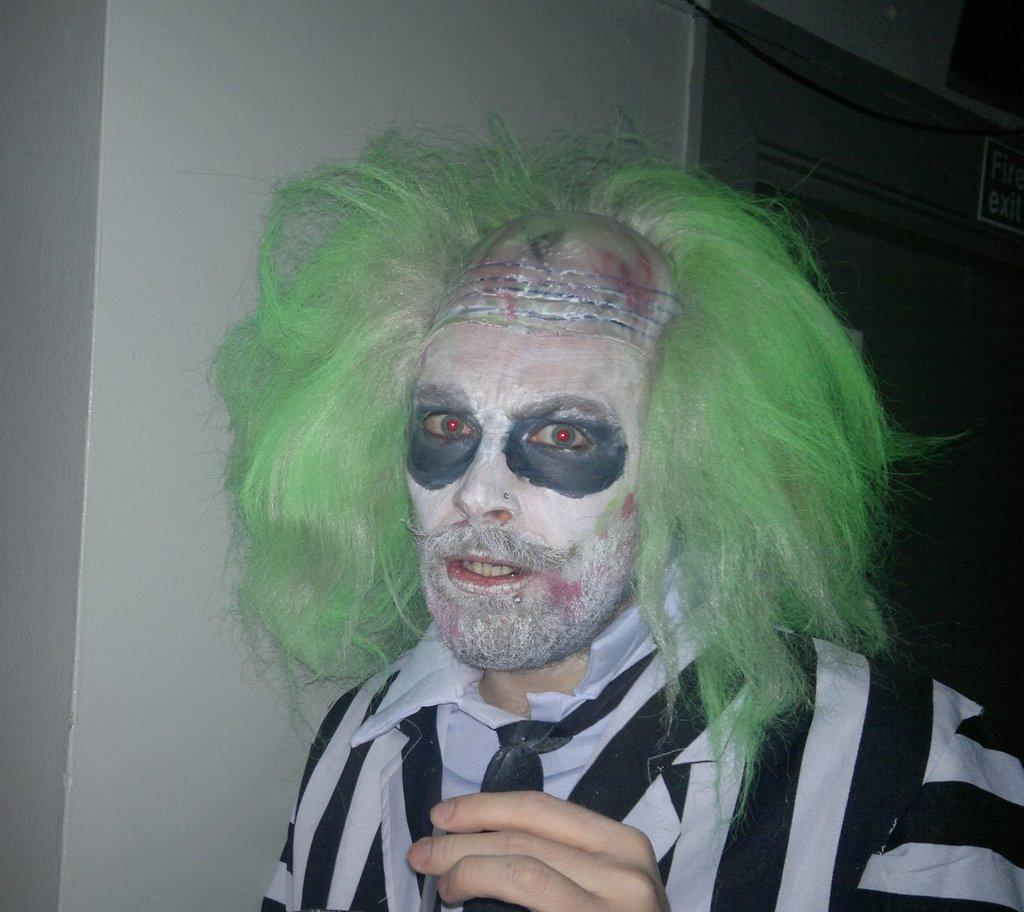What is the man in the image wearing? The man is wearing a costume in the image. What theme does the costume suggest? The costume suggests a Halloween theme. What can be seen in the background of the image? There is a wall and a door in the background of the image. What type of music is the band playing in the image? There is no band present in the image, so it's not possible to determine what type of music they might be playing. 